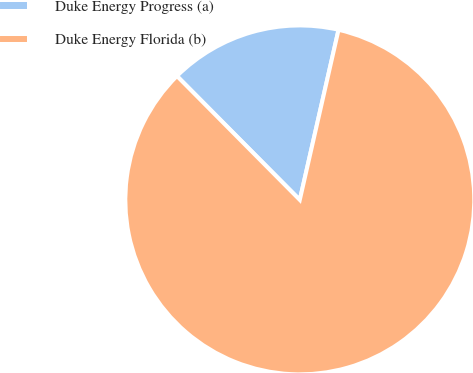Convert chart to OTSL. <chart><loc_0><loc_0><loc_500><loc_500><pie_chart><fcel>Duke Energy Progress (a)<fcel>Duke Energy Florida (b)<nl><fcel>16.0%<fcel>84.0%<nl></chart> 